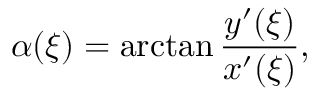Convert formula to latex. <formula><loc_0><loc_0><loc_500><loc_500>\alpha ( \xi ) = \arctan \frac { y ^ { \prime } ( \xi ) } { x ^ { \prime } ( \xi ) } ,</formula> 